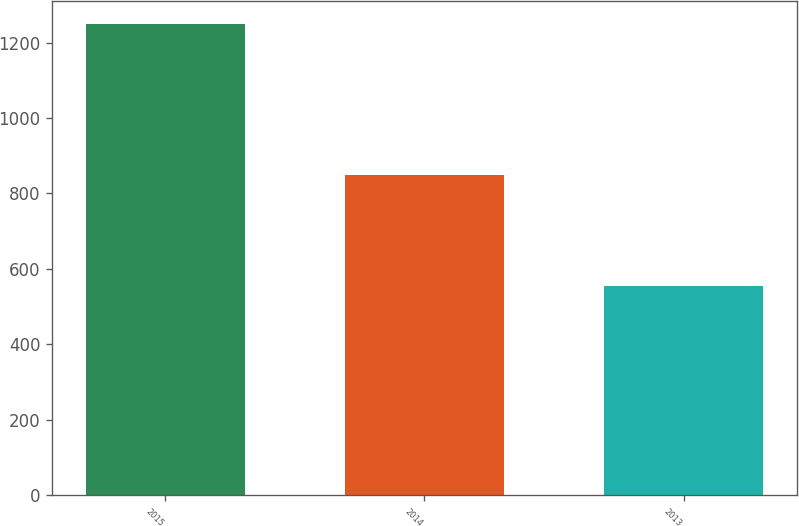<chart> <loc_0><loc_0><loc_500><loc_500><bar_chart><fcel>2015<fcel>2014<fcel>2013<nl><fcel>1248<fcel>850<fcel>555<nl></chart> 